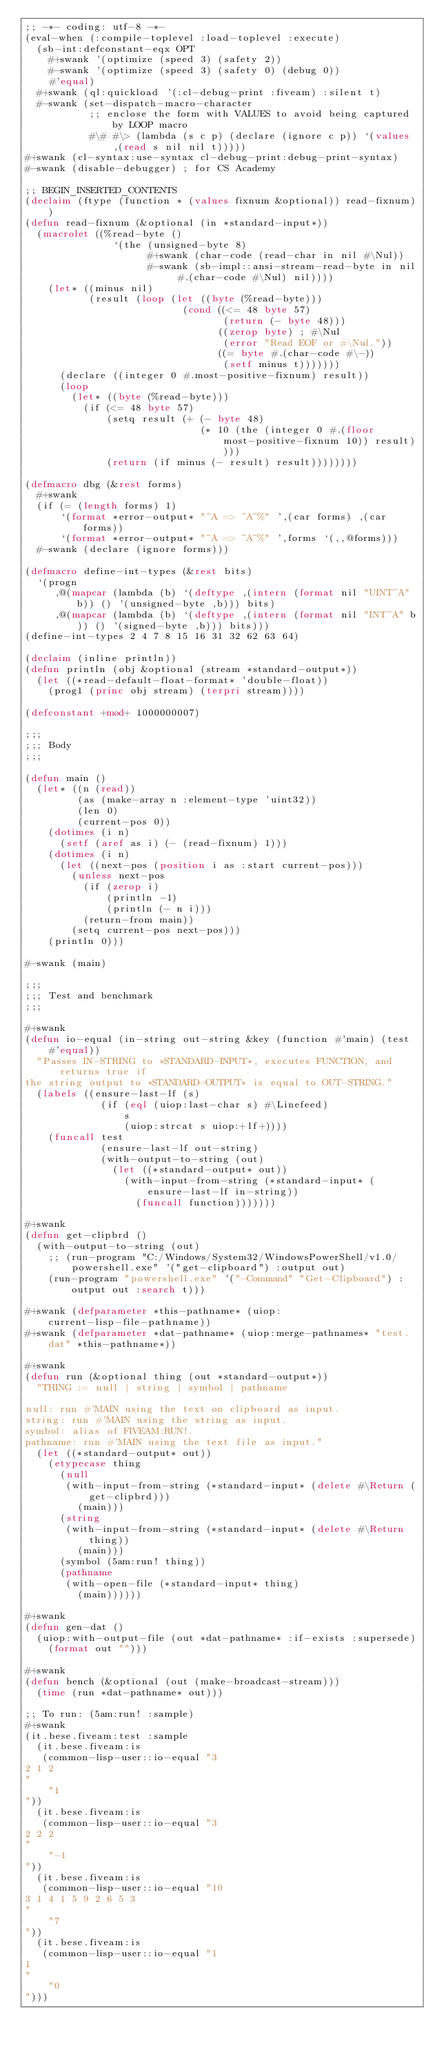Convert code to text. <code><loc_0><loc_0><loc_500><loc_500><_Lisp_>;; -*- coding: utf-8 -*-
(eval-when (:compile-toplevel :load-toplevel :execute)
  (sb-int:defconstant-eqx OPT
    #+swank '(optimize (speed 3) (safety 2))
    #-swank '(optimize (speed 3) (safety 0) (debug 0))
    #'equal)
  #+swank (ql:quickload '(:cl-debug-print :fiveam) :silent t)
  #-swank (set-dispatch-macro-character
           ;; enclose the form with VALUES to avoid being captured by LOOP macro
           #\# #\> (lambda (s c p) (declare (ignore c p)) `(values ,(read s nil nil t)))))
#+swank (cl-syntax:use-syntax cl-debug-print:debug-print-syntax)
#-swank (disable-debugger) ; for CS Academy

;; BEGIN_INSERTED_CONTENTS
(declaim (ftype (function * (values fixnum &optional)) read-fixnum))
(defun read-fixnum (&optional (in *standard-input*))
  (macrolet ((%read-byte ()
               `(the (unsigned-byte 8)
                     #+swank (char-code (read-char in nil #\Nul))
                     #-swank (sb-impl::ansi-stream-read-byte in nil #.(char-code #\Nul) nil))))
    (let* ((minus nil)
           (result (loop (let ((byte (%read-byte)))
                           (cond ((<= 48 byte 57)
                                  (return (- byte 48)))
                                 ((zerop byte) ; #\Nul
                                  (error "Read EOF or #\Nul."))
                                 ((= byte #.(char-code #\-))
                                  (setf minus t)))))))
      (declare ((integer 0 #.most-positive-fixnum) result))
      (loop
        (let* ((byte (%read-byte)))
          (if (<= 48 byte 57)
              (setq result (+ (- byte 48)
                              (* 10 (the (integer 0 #.(floor most-positive-fixnum 10)) result))))
              (return (if minus (- result) result))))))))

(defmacro dbg (&rest forms)
  #+swank
  (if (= (length forms) 1)
      `(format *error-output* "~A => ~A~%" ',(car forms) ,(car forms))
      `(format *error-output* "~A => ~A~%" ',forms `(,,@forms)))
  #-swank (declare (ignore forms)))

(defmacro define-int-types (&rest bits)
  `(progn
     ,@(mapcar (lambda (b) `(deftype ,(intern (format nil "UINT~A" b)) () '(unsigned-byte ,b))) bits)
     ,@(mapcar (lambda (b) `(deftype ,(intern (format nil "INT~A" b)) () '(signed-byte ,b))) bits)))
(define-int-types 2 4 7 8 15 16 31 32 62 63 64)

(declaim (inline println))
(defun println (obj &optional (stream *standard-output*))
  (let ((*read-default-float-format* 'double-float))
    (prog1 (princ obj stream) (terpri stream))))

(defconstant +mod+ 1000000007)

;;;
;;; Body
;;;

(defun main ()
  (let* ((n (read))
         (as (make-array n :element-type 'uint32))
         (len 0)
         (current-pos 0))
    (dotimes (i n)
      (setf (aref as i) (- (read-fixnum) 1)))
    (dotimes (i n)
      (let ((next-pos (position i as :start current-pos)))
        (unless next-pos
          (if (zerop i)
              (println -1)
              (println (- n i)))
          (return-from main))
        (setq current-pos next-pos)))
    (println 0)))

#-swank (main)

;;;
;;; Test and benchmark
;;;

#+swank
(defun io-equal (in-string out-string &key (function #'main) (test #'equal))
  "Passes IN-STRING to *STANDARD-INPUT*, executes FUNCTION, and returns true if
the string output to *STANDARD-OUTPUT* is equal to OUT-STRING."
  (labels ((ensure-last-lf (s)
             (if (eql (uiop:last-char s) #\Linefeed)
                 s
                 (uiop:strcat s uiop:+lf+))))
    (funcall test
             (ensure-last-lf out-string)
             (with-output-to-string (out)
               (let ((*standard-output* out))
                 (with-input-from-string (*standard-input* (ensure-last-lf in-string))
                   (funcall function)))))))

#+swank
(defun get-clipbrd ()
  (with-output-to-string (out)
    ;; (run-program "C:/Windows/System32/WindowsPowerShell/v1.0/powershell.exe" '("get-clipboard") :output out)
    (run-program "powershell.exe" '("-Command" "Get-Clipboard") :output out :search t)))

#+swank (defparameter *this-pathname* (uiop:current-lisp-file-pathname))
#+swank (defparameter *dat-pathname* (uiop:merge-pathnames* "test.dat" *this-pathname*))

#+swank
(defun run (&optional thing (out *standard-output*))
  "THING := null | string | symbol | pathname

null: run #'MAIN using the text on clipboard as input.
string: run #'MAIN using the string as input.
symbol: alias of FIVEAM:RUN!.
pathname: run #'MAIN using the text file as input."
  (let ((*standard-output* out))
    (etypecase thing
      (null
       (with-input-from-string (*standard-input* (delete #\Return (get-clipbrd)))
         (main)))
      (string
       (with-input-from-string (*standard-input* (delete #\Return thing))
         (main)))
      (symbol (5am:run! thing))
      (pathname
       (with-open-file (*standard-input* thing)
         (main))))))

#+swank
(defun gen-dat ()
  (uiop:with-output-file (out *dat-pathname* :if-exists :supersede)
    (format out "")))

#+swank
(defun bench (&optional (out (make-broadcast-stream)))
  (time (run *dat-pathname* out)))

;; To run: (5am:run! :sample)
#+swank
(it.bese.fiveam:test :sample
  (it.bese.fiveam:is
   (common-lisp-user::io-equal "3
2 1 2
"
    "1
"))
  (it.bese.fiveam:is
   (common-lisp-user::io-equal "3
2 2 2
"
    "-1
"))
  (it.bese.fiveam:is
   (common-lisp-user::io-equal "10
3 1 4 1 5 9 2 6 5 3
"
    "7
"))
  (it.bese.fiveam:is
   (common-lisp-user::io-equal "1
1
"
    "0
")))
</code> 